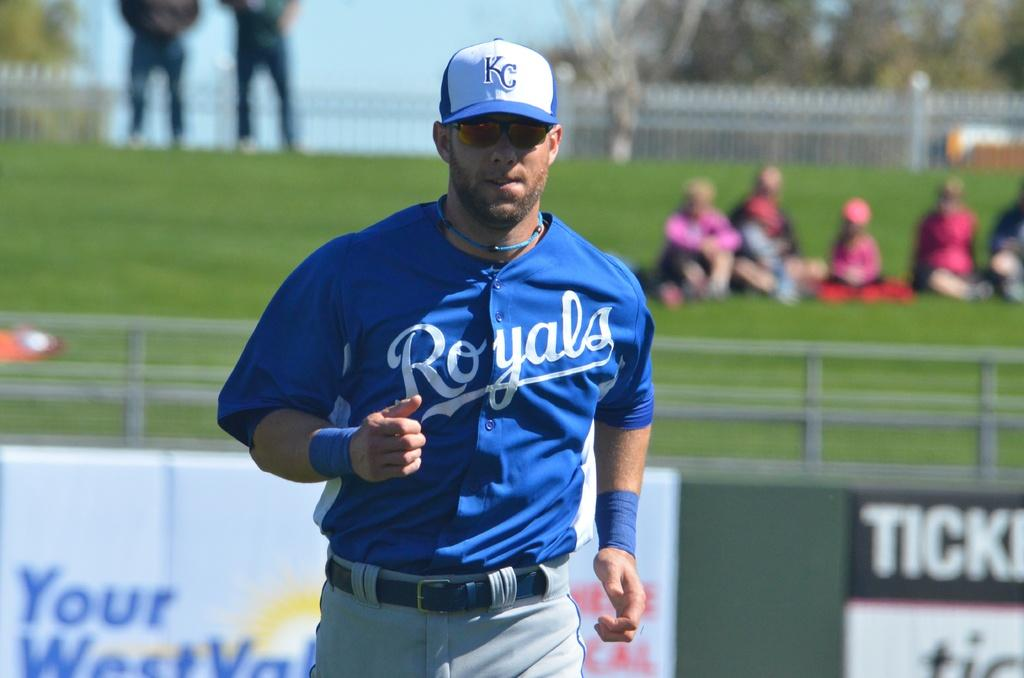<image>
Offer a succinct explanation of the picture presented. A man in a Royals uniform is wearing a hat that says KC on it. 